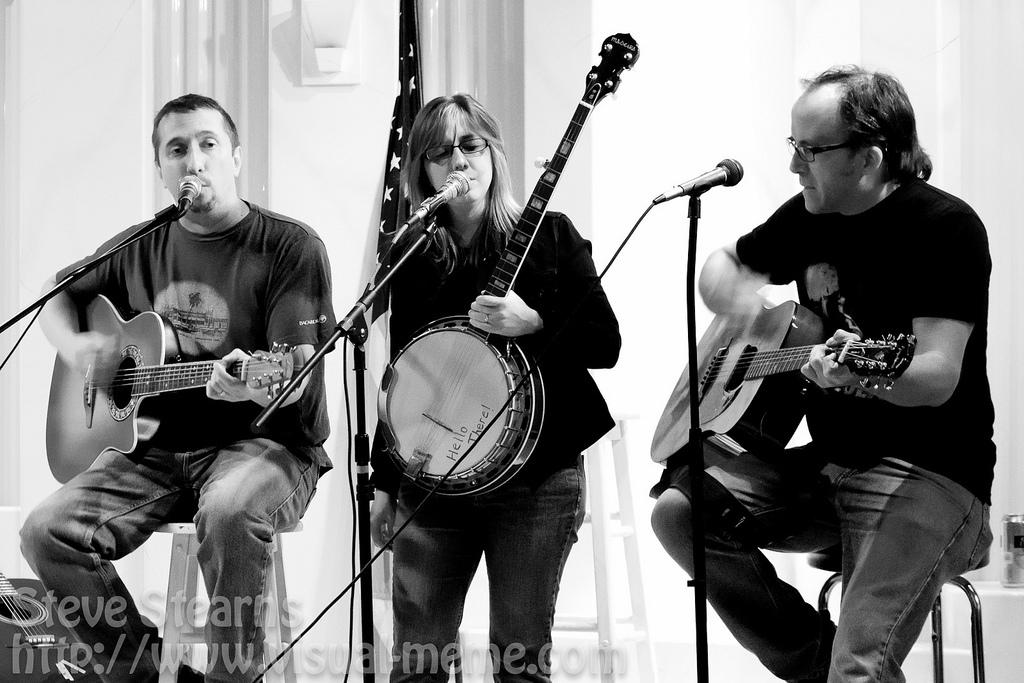How many people are in the image? There are three people in the image. What are the men doing in the image? The men are seated on chairs and playing guitars. What is the woman doing in the image? The woman is standing. What objects are in front of the men playing guitars? The guitars are in front of microphones. What type of shirt is the woman wearing in the image? There is no information about the woman's shirt in the image. Can you tell me if there is a hospital in the background of the image? There is no mention of a hospital or any medical setting in the image. 